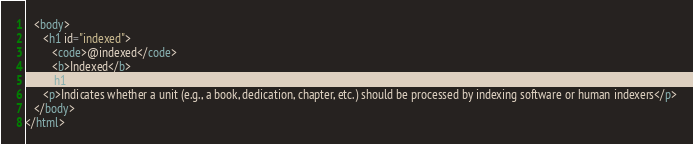Convert code to text. <code><loc_0><loc_0><loc_500><loc_500><_HTML_>   <body>
      <h1 id="indexed">
         <code>@indexed</code> 
         <b>Indexed</b>
      </h1>
      <p>Indicates whether a unit (e.g., a book, dedication, chapter, etc.) should be processed by indexing software or human indexers</p>
   </body>
</html>
</code> 